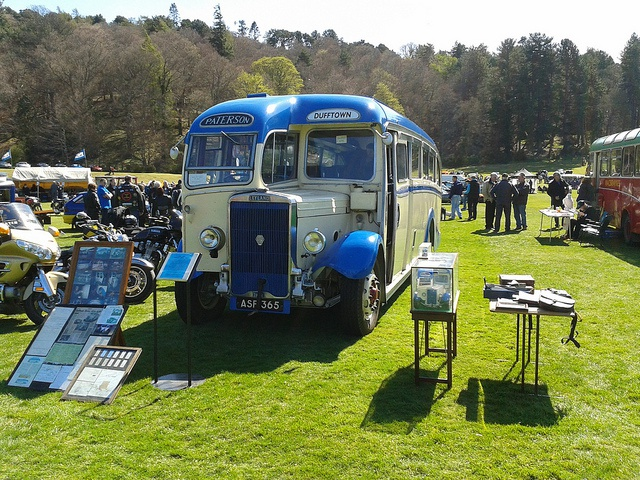Describe the objects in this image and their specific colors. I can see bus in lightblue, black, gray, darkgray, and navy tones, motorcycle in lightblue, black, white, gray, and olive tones, bus in lightblue, black, gray, and maroon tones, dining table in lightblue, black, olive, and khaki tones, and motorcycle in lightblue, black, gray, and darkblue tones in this image. 